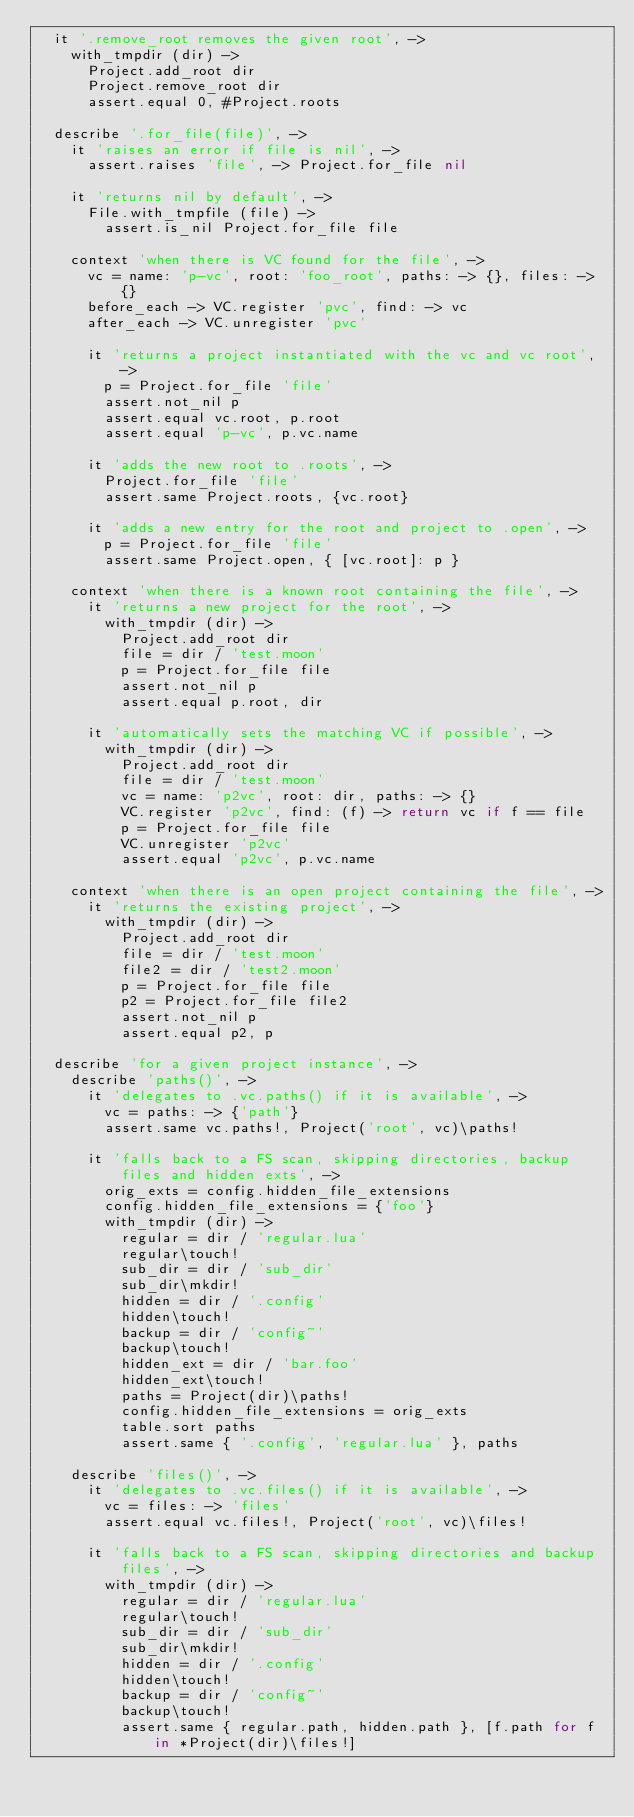<code> <loc_0><loc_0><loc_500><loc_500><_MoonScript_>  it '.remove_root removes the given root', ->
    with_tmpdir (dir) ->
      Project.add_root dir
      Project.remove_root dir
      assert.equal 0, #Project.roots

  describe '.for_file(file)', ->
    it 'raises an error if file is nil', ->
      assert.raises 'file', -> Project.for_file nil

    it 'returns nil by default', ->
      File.with_tmpfile (file) ->
        assert.is_nil Project.for_file file

    context 'when there is VC found for the file', ->
      vc = name: 'p-vc', root: 'foo_root', paths: -> {}, files: -> {}
      before_each -> VC.register 'pvc', find: -> vc
      after_each -> VC.unregister 'pvc'

      it 'returns a project instantiated with the vc and vc root', ->
        p = Project.for_file 'file'
        assert.not_nil p
        assert.equal vc.root, p.root
        assert.equal 'p-vc', p.vc.name

      it 'adds the new root to .roots', ->
        Project.for_file 'file'
        assert.same Project.roots, {vc.root}

      it 'adds a new entry for the root and project to .open', ->
        p = Project.for_file 'file'
        assert.same Project.open, { [vc.root]: p }

    context 'when there is a known root containing the file', ->
      it 'returns a new project for the root', ->
        with_tmpdir (dir) ->
          Project.add_root dir
          file = dir / 'test.moon'
          p = Project.for_file file
          assert.not_nil p
          assert.equal p.root, dir

      it 'automatically sets the matching VC if possible', ->
        with_tmpdir (dir) ->
          Project.add_root dir
          file = dir / 'test.moon'
          vc = name: 'p2vc', root: dir, paths: -> {}
          VC.register 'p2vc', find: (f) -> return vc if f == file
          p = Project.for_file file
          VC.unregister 'p2vc'
          assert.equal 'p2vc', p.vc.name

    context 'when there is an open project containing the file', ->
      it 'returns the existing project', ->
        with_tmpdir (dir) ->
          Project.add_root dir
          file = dir / 'test.moon'
          file2 = dir / 'test2.moon'
          p = Project.for_file file
          p2 = Project.for_file file2
          assert.not_nil p
          assert.equal p2, p

  describe 'for a given project instance', ->
    describe 'paths()', ->
      it 'delegates to .vc.paths() if it is available', ->
        vc = paths: -> {'path'}
        assert.same vc.paths!, Project('root', vc)\paths!

      it 'falls back to a FS scan, skipping directories, backup files and hidden exts', ->
        orig_exts = config.hidden_file_extensions
        config.hidden_file_extensions = {'foo'}
        with_tmpdir (dir) ->
          regular = dir / 'regular.lua'
          regular\touch!
          sub_dir = dir / 'sub_dir'
          sub_dir\mkdir!
          hidden = dir / '.config'
          hidden\touch!
          backup = dir / 'config~'
          backup\touch!
          hidden_ext = dir / 'bar.foo'
          hidden_ext\touch!
          paths = Project(dir)\paths!
          config.hidden_file_extensions = orig_exts
          table.sort paths
          assert.same { '.config', 'regular.lua' }, paths

    describe 'files()', ->
      it 'delegates to .vc.files() if it is available', ->
        vc = files: -> 'files'
        assert.equal vc.files!, Project('root', vc)\files!

      it 'falls back to a FS scan, skipping directories and backup files', ->
        with_tmpdir (dir) ->
          regular = dir / 'regular.lua'
          regular\touch!
          sub_dir = dir / 'sub_dir'
          sub_dir\mkdir!
          hidden = dir / '.config'
          hidden\touch!
          backup = dir / 'config~'
          backup\touch!
          assert.same { regular.path, hidden.path }, [f.path for f in *Project(dir)\files!]
</code> 